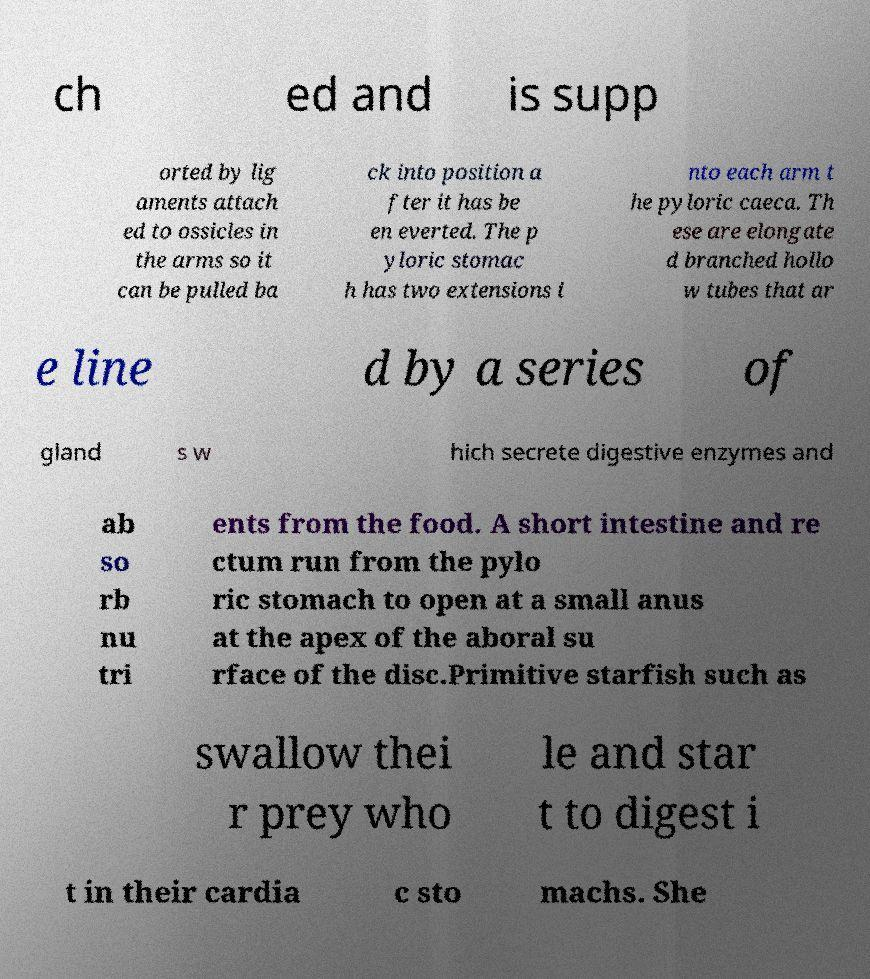For documentation purposes, I need the text within this image transcribed. Could you provide that? ch ed and is supp orted by lig aments attach ed to ossicles in the arms so it can be pulled ba ck into position a fter it has be en everted. The p yloric stomac h has two extensions i nto each arm t he pyloric caeca. Th ese are elongate d branched hollo w tubes that ar e line d by a series of gland s w hich secrete digestive enzymes and ab so rb nu tri ents from the food. A short intestine and re ctum run from the pylo ric stomach to open at a small anus at the apex of the aboral su rface of the disc.Primitive starfish such as swallow thei r prey who le and star t to digest i t in their cardia c sto machs. She 